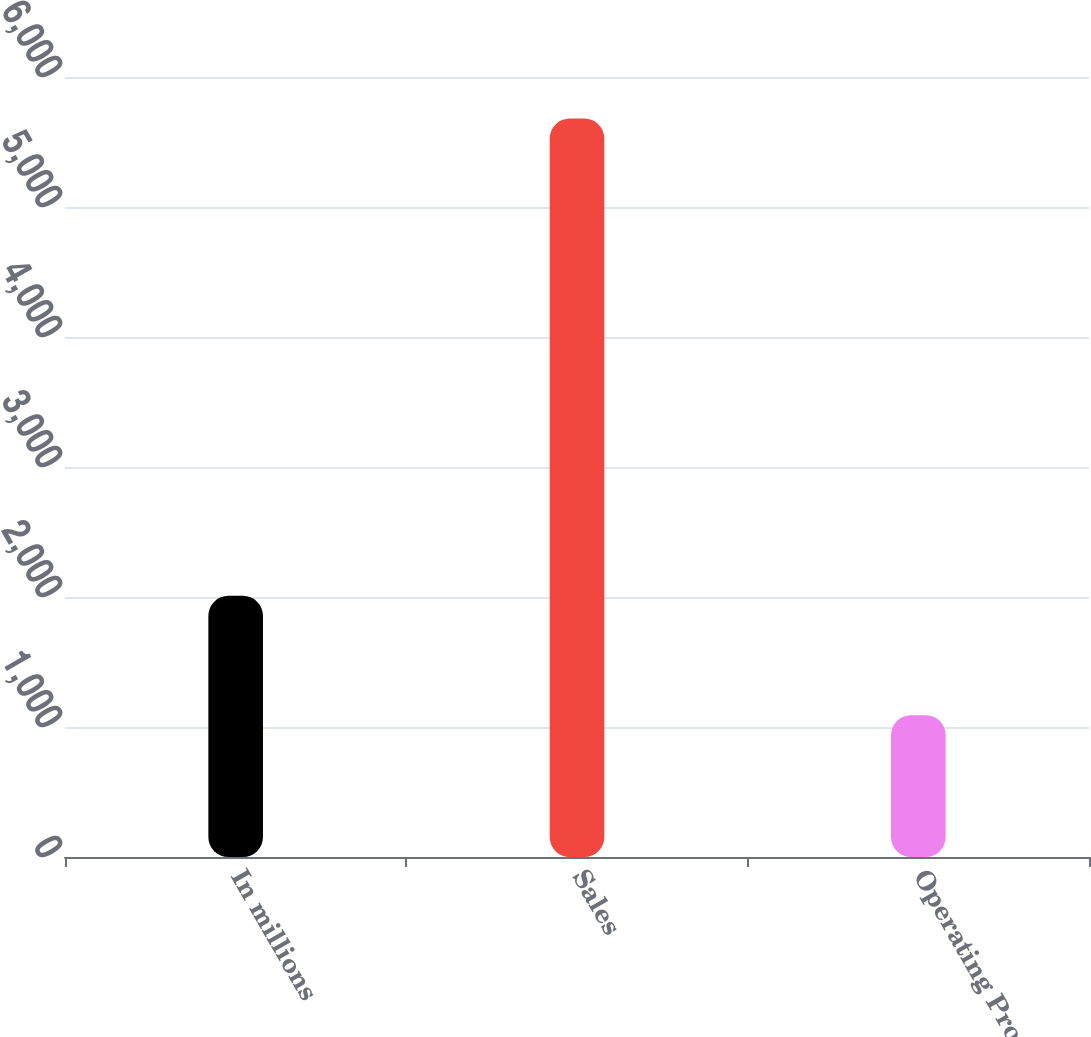Convert chart to OTSL. <chart><loc_0><loc_0><loc_500><loc_500><bar_chart><fcel>In millions<fcel>Sales<fcel>Operating Profit<nl><fcel>2009<fcel>5680<fcel>1091<nl></chart> 